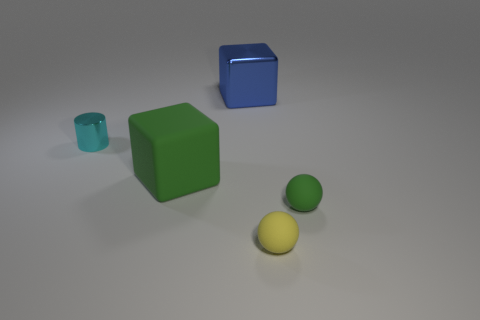There is a tiny metal object; is its color the same as the ball that is to the right of the yellow matte sphere?
Keep it short and to the point. No. What number of other things are the same size as the blue metallic cube?
Offer a very short reply. 1. What is the size of the sphere that is the same color as the large matte cube?
Offer a very short reply. Small. How many blocks are either small cyan objects or small objects?
Offer a terse response. 0. Do the tiny green object in front of the large green block and the large green thing have the same shape?
Make the answer very short. No. Are there more large blue things on the right side of the small green matte thing than tiny cyan matte balls?
Your answer should be very brief. No. The rubber object that is the same size as the blue shiny object is what color?
Your answer should be compact. Green. What number of objects are green objects that are to the left of the large blue metallic block or large green rubber cubes?
Give a very brief answer. 1. There is a cyan thing that is left of the block that is in front of the tiny cyan object; what is it made of?
Provide a short and direct response. Metal. Is there a big red cube made of the same material as the cylinder?
Ensure brevity in your answer.  No. 